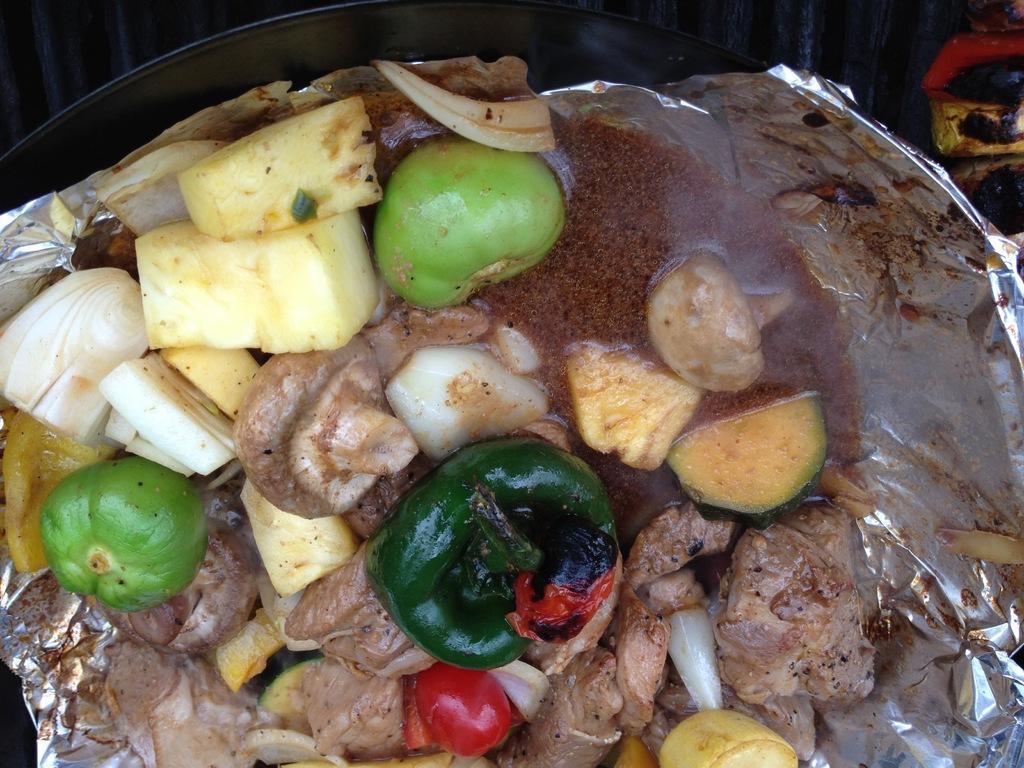How would you summarize this image in a sentence or two? In the center of the image we can see one plate. In the plate, we can see one silver paper. In the silver paper, we can see some food items. In the background we can see a few other objects. 